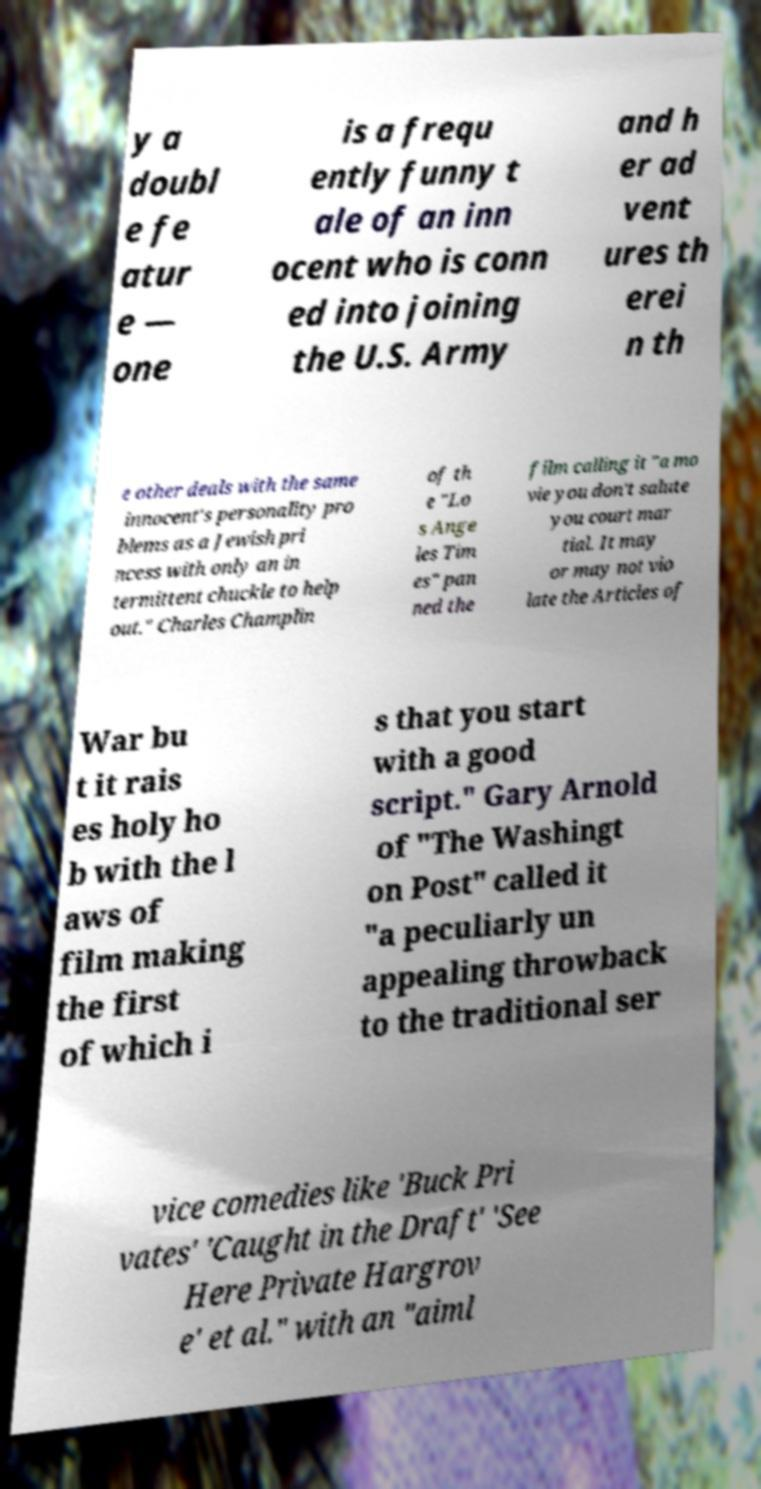For documentation purposes, I need the text within this image transcribed. Could you provide that? y a doubl e fe atur e — one is a frequ ently funny t ale of an inn ocent who is conn ed into joining the U.S. Army and h er ad vent ures th erei n th e other deals with the same innocent's personality pro blems as a Jewish pri ncess with only an in termittent chuckle to help out." Charles Champlin of th e "Lo s Ange les Tim es" pan ned the film calling it "a mo vie you don't salute you court mar tial. It may or may not vio late the Articles of War bu t it rais es holy ho b with the l aws of film making the first of which i s that you start with a good script." Gary Arnold of "The Washingt on Post" called it "a peculiarly un appealing throwback to the traditional ser vice comedies like 'Buck Pri vates' 'Caught in the Draft' 'See Here Private Hargrov e' et al." with an "aiml 